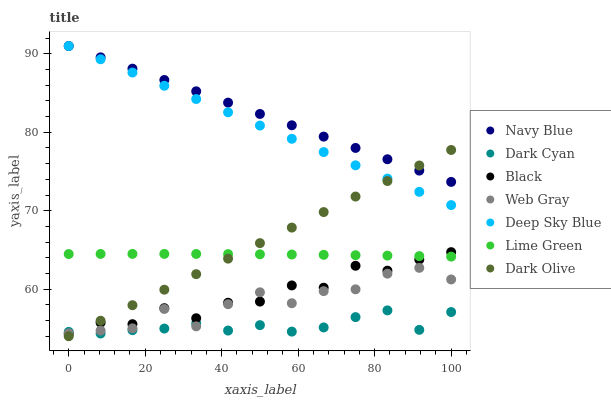Does Dark Cyan have the minimum area under the curve?
Answer yes or no. Yes. Does Navy Blue have the maximum area under the curve?
Answer yes or no. Yes. Does Dark Olive have the minimum area under the curve?
Answer yes or no. No. Does Dark Olive have the maximum area under the curve?
Answer yes or no. No. Is Dark Olive the smoothest?
Answer yes or no. Yes. Is Web Gray the roughest?
Answer yes or no. Yes. Is Navy Blue the smoothest?
Answer yes or no. No. Is Navy Blue the roughest?
Answer yes or no. No. Does Dark Olive have the lowest value?
Answer yes or no. Yes. Does Navy Blue have the lowest value?
Answer yes or no. No. Does Deep Sky Blue have the highest value?
Answer yes or no. Yes. Does Dark Olive have the highest value?
Answer yes or no. No. Is Dark Cyan less than Navy Blue?
Answer yes or no. Yes. Is Deep Sky Blue greater than Dark Cyan?
Answer yes or no. Yes. Does Deep Sky Blue intersect Dark Olive?
Answer yes or no. Yes. Is Deep Sky Blue less than Dark Olive?
Answer yes or no. No. Is Deep Sky Blue greater than Dark Olive?
Answer yes or no. No. Does Dark Cyan intersect Navy Blue?
Answer yes or no. No. 